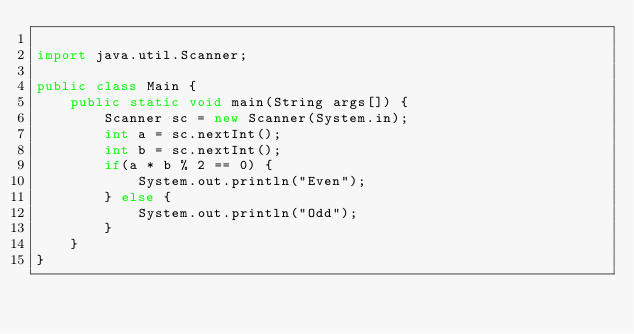<code> <loc_0><loc_0><loc_500><loc_500><_Java_>
import java.util.Scanner;

public class Main {
	public static void main(String args[]) {
		Scanner sc = new Scanner(System.in);
		int a = sc.nextInt();
		int b = sc.nextInt();
		if(a * b % 2 == 0) {
			System.out.println("Even");
		} else {
			System.out.println("Odd");
		}
	}
}
</code> 